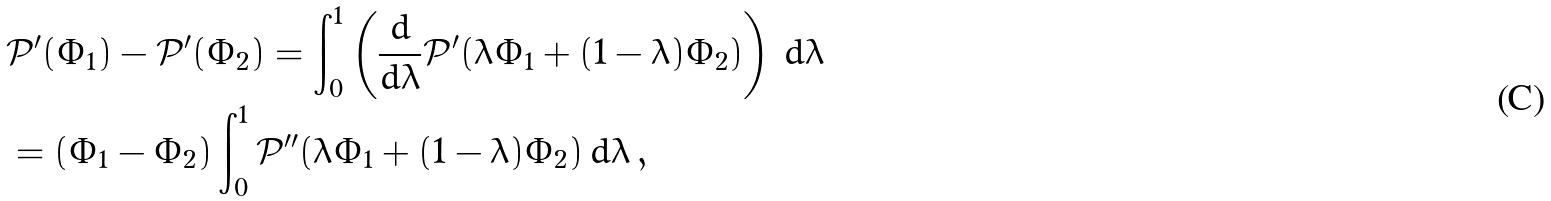Convert formula to latex. <formula><loc_0><loc_0><loc_500><loc_500>& \mathcal { P } ^ { \prime } ( \Phi _ { 1 } ) - \mathcal { P } ^ { \prime } ( \Phi _ { 2 } ) = \int _ { 0 } ^ { 1 } \left ( \frac { d } { d \lambda } \mathcal { P } ^ { \prime } ( \lambda \Phi _ { 1 } + ( 1 - \lambda ) \Phi _ { 2 } ) \right ) \, d \lambda \\ & = ( \Phi _ { 1 } - \Phi _ { 2 } ) \int _ { 0 } ^ { 1 } \mathcal { P } ^ { \prime \prime } ( \lambda \Phi _ { 1 } + ( 1 - \lambda ) \Phi _ { 2 } ) \, d \lambda \, , \\</formula> 